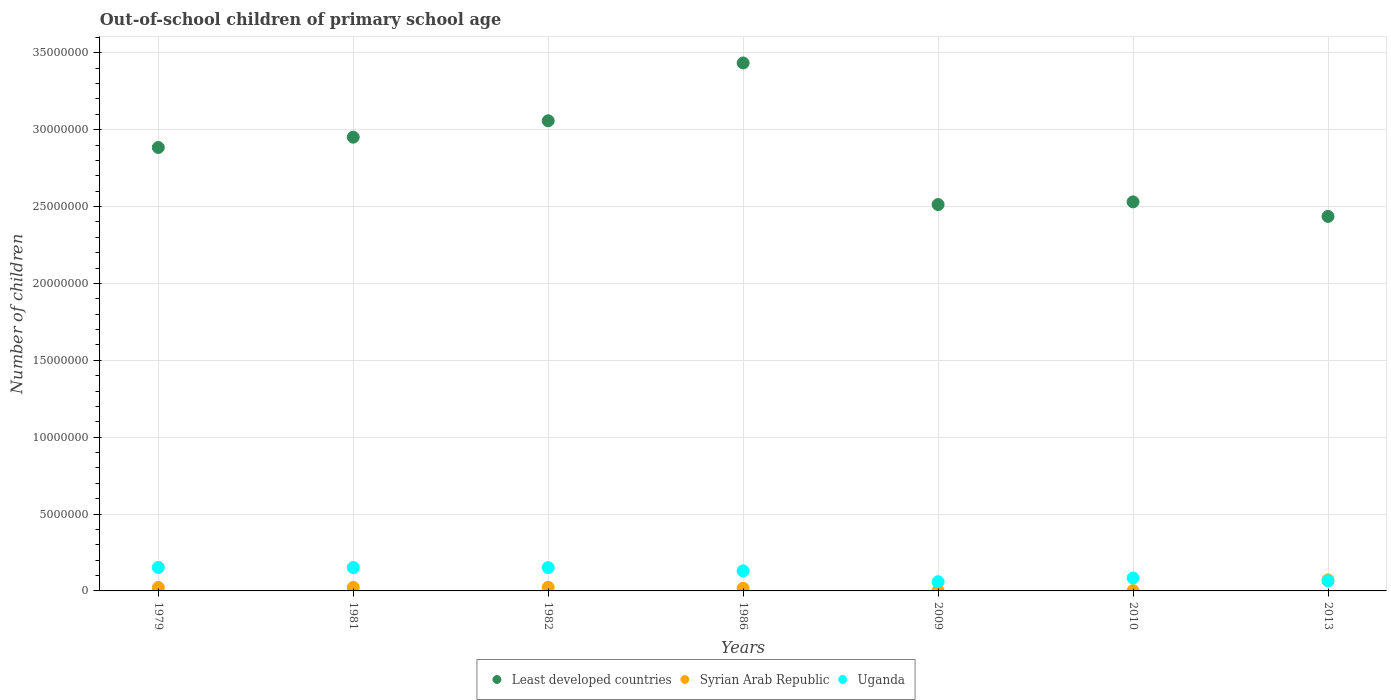What is the number of out-of-school children in Least developed countries in 2013?
Provide a succinct answer. 2.44e+07. Across all years, what is the maximum number of out-of-school children in Uganda?
Make the answer very short. 1.52e+06. Across all years, what is the minimum number of out-of-school children in Syrian Arab Republic?
Offer a very short reply. 1.86e+04. In which year was the number of out-of-school children in Least developed countries maximum?
Provide a succinct answer. 1986. In which year was the number of out-of-school children in Least developed countries minimum?
Offer a terse response. 2013. What is the total number of out-of-school children in Uganda in the graph?
Your answer should be very brief. 7.97e+06. What is the difference between the number of out-of-school children in Uganda in 1981 and that in 2009?
Offer a terse response. 9.25e+05. What is the difference between the number of out-of-school children in Least developed countries in 2013 and the number of out-of-school children in Uganda in 1981?
Provide a short and direct response. 2.28e+07. What is the average number of out-of-school children in Uganda per year?
Make the answer very short. 1.14e+06. In the year 2009, what is the difference between the number of out-of-school children in Syrian Arab Republic and number of out-of-school children in Uganda?
Make the answer very short. -5.76e+05. In how many years, is the number of out-of-school children in Syrian Arab Republic greater than 8000000?
Your answer should be very brief. 0. What is the ratio of the number of out-of-school children in Syrian Arab Republic in 2009 to that in 2010?
Give a very brief answer. 1.04. Is the number of out-of-school children in Syrian Arab Republic in 1986 less than that in 2013?
Keep it short and to the point. Yes. What is the difference between the highest and the second highest number of out-of-school children in Least developed countries?
Offer a terse response. 3.76e+06. What is the difference between the highest and the lowest number of out-of-school children in Least developed countries?
Your answer should be very brief. 9.98e+06. In how many years, is the number of out-of-school children in Least developed countries greater than the average number of out-of-school children in Least developed countries taken over all years?
Provide a succinct answer. 4. How many years are there in the graph?
Ensure brevity in your answer.  7. What is the difference between two consecutive major ticks on the Y-axis?
Provide a succinct answer. 5.00e+06. Are the values on the major ticks of Y-axis written in scientific E-notation?
Make the answer very short. No. Does the graph contain any zero values?
Your answer should be compact. No. How many legend labels are there?
Make the answer very short. 3. What is the title of the graph?
Provide a short and direct response. Out-of-school children of primary school age. Does "Namibia" appear as one of the legend labels in the graph?
Offer a terse response. No. What is the label or title of the Y-axis?
Ensure brevity in your answer.  Number of children. What is the Number of children of Least developed countries in 1979?
Your answer should be very brief. 2.88e+07. What is the Number of children of Syrian Arab Republic in 1979?
Your response must be concise. 2.24e+05. What is the Number of children in Uganda in 1979?
Make the answer very short. 1.52e+06. What is the Number of children of Least developed countries in 1981?
Offer a very short reply. 2.95e+07. What is the Number of children in Syrian Arab Republic in 1981?
Your answer should be compact. 2.28e+05. What is the Number of children in Uganda in 1981?
Your answer should be very brief. 1.52e+06. What is the Number of children of Least developed countries in 1982?
Offer a very short reply. 3.06e+07. What is the Number of children in Syrian Arab Republic in 1982?
Your response must be concise. 2.33e+05. What is the Number of children of Uganda in 1982?
Your answer should be compact. 1.52e+06. What is the Number of children in Least developed countries in 1986?
Provide a succinct answer. 3.43e+07. What is the Number of children in Syrian Arab Republic in 1986?
Offer a terse response. 1.64e+05. What is the Number of children in Uganda in 1986?
Your answer should be very brief. 1.30e+06. What is the Number of children of Least developed countries in 2009?
Keep it short and to the point. 2.51e+07. What is the Number of children of Syrian Arab Republic in 2009?
Keep it short and to the point. 1.94e+04. What is the Number of children in Uganda in 2009?
Offer a very short reply. 5.96e+05. What is the Number of children in Least developed countries in 2010?
Ensure brevity in your answer.  2.53e+07. What is the Number of children of Syrian Arab Republic in 2010?
Ensure brevity in your answer.  1.86e+04. What is the Number of children in Uganda in 2010?
Your response must be concise. 8.40e+05. What is the Number of children of Least developed countries in 2013?
Offer a very short reply. 2.44e+07. What is the Number of children of Syrian Arab Republic in 2013?
Ensure brevity in your answer.  7.16e+05. What is the Number of children of Uganda in 2013?
Provide a succinct answer. 6.60e+05. Across all years, what is the maximum Number of children of Least developed countries?
Ensure brevity in your answer.  3.43e+07. Across all years, what is the maximum Number of children of Syrian Arab Republic?
Provide a short and direct response. 7.16e+05. Across all years, what is the maximum Number of children of Uganda?
Your response must be concise. 1.52e+06. Across all years, what is the minimum Number of children of Least developed countries?
Your answer should be compact. 2.44e+07. Across all years, what is the minimum Number of children of Syrian Arab Republic?
Offer a very short reply. 1.86e+04. Across all years, what is the minimum Number of children of Uganda?
Your answer should be compact. 5.96e+05. What is the total Number of children in Least developed countries in the graph?
Ensure brevity in your answer.  1.98e+08. What is the total Number of children in Syrian Arab Republic in the graph?
Offer a terse response. 1.60e+06. What is the total Number of children in Uganda in the graph?
Your response must be concise. 7.97e+06. What is the difference between the Number of children of Least developed countries in 1979 and that in 1981?
Provide a succinct answer. -6.71e+05. What is the difference between the Number of children of Syrian Arab Republic in 1979 and that in 1981?
Give a very brief answer. -4210. What is the difference between the Number of children of Uganda in 1979 and that in 1981?
Your response must be concise. 4531. What is the difference between the Number of children in Least developed countries in 1979 and that in 1982?
Provide a short and direct response. -1.74e+06. What is the difference between the Number of children in Syrian Arab Republic in 1979 and that in 1982?
Make the answer very short. -9060. What is the difference between the Number of children of Uganda in 1979 and that in 1982?
Provide a short and direct response. 4746. What is the difference between the Number of children in Least developed countries in 1979 and that in 1986?
Provide a succinct answer. -5.50e+06. What is the difference between the Number of children of Syrian Arab Republic in 1979 and that in 1986?
Offer a very short reply. 5.96e+04. What is the difference between the Number of children in Uganda in 1979 and that in 1986?
Your answer should be compact. 2.20e+05. What is the difference between the Number of children of Least developed countries in 1979 and that in 2009?
Give a very brief answer. 3.71e+06. What is the difference between the Number of children of Syrian Arab Republic in 1979 and that in 2009?
Your response must be concise. 2.05e+05. What is the difference between the Number of children in Uganda in 1979 and that in 2009?
Provide a short and direct response. 9.29e+05. What is the difference between the Number of children in Least developed countries in 1979 and that in 2010?
Your answer should be very brief. 3.54e+06. What is the difference between the Number of children in Syrian Arab Republic in 1979 and that in 2010?
Give a very brief answer. 2.05e+05. What is the difference between the Number of children in Uganda in 1979 and that in 2010?
Provide a succinct answer. 6.84e+05. What is the difference between the Number of children in Least developed countries in 1979 and that in 2013?
Give a very brief answer. 4.48e+06. What is the difference between the Number of children of Syrian Arab Republic in 1979 and that in 2013?
Make the answer very short. -4.92e+05. What is the difference between the Number of children in Uganda in 1979 and that in 2013?
Your response must be concise. 8.65e+05. What is the difference between the Number of children in Least developed countries in 1981 and that in 1982?
Give a very brief answer. -1.07e+06. What is the difference between the Number of children in Syrian Arab Republic in 1981 and that in 1982?
Provide a short and direct response. -4850. What is the difference between the Number of children in Uganda in 1981 and that in 1982?
Your answer should be compact. 215. What is the difference between the Number of children of Least developed countries in 1981 and that in 1986?
Your response must be concise. -4.83e+06. What is the difference between the Number of children of Syrian Arab Republic in 1981 and that in 1986?
Ensure brevity in your answer.  6.38e+04. What is the difference between the Number of children of Uganda in 1981 and that in 1986?
Offer a very short reply. 2.16e+05. What is the difference between the Number of children in Least developed countries in 1981 and that in 2009?
Keep it short and to the point. 4.38e+06. What is the difference between the Number of children of Syrian Arab Republic in 1981 and that in 2009?
Ensure brevity in your answer.  2.09e+05. What is the difference between the Number of children in Uganda in 1981 and that in 2009?
Your answer should be compact. 9.25e+05. What is the difference between the Number of children of Least developed countries in 1981 and that in 2010?
Your response must be concise. 4.21e+06. What is the difference between the Number of children in Syrian Arab Republic in 1981 and that in 2010?
Offer a very short reply. 2.10e+05. What is the difference between the Number of children in Uganda in 1981 and that in 2010?
Your answer should be compact. 6.80e+05. What is the difference between the Number of children of Least developed countries in 1981 and that in 2013?
Your response must be concise. 5.15e+06. What is the difference between the Number of children of Syrian Arab Republic in 1981 and that in 2013?
Your response must be concise. -4.87e+05. What is the difference between the Number of children of Uganda in 1981 and that in 2013?
Give a very brief answer. 8.60e+05. What is the difference between the Number of children in Least developed countries in 1982 and that in 1986?
Give a very brief answer. -3.76e+06. What is the difference between the Number of children in Syrian Arab Republic in 1982 and that in 1986?
Your answer should be compact. 6.86e+04. What is the difference between the Number of children of Uganda in 1982 and that in 1986?
Make the answer very short. 2.15e+05. What is the difference between the Number of children in Least developed countries in 1982 and that in 2009?
Provide a short and direct response. 5.45e+06. What is the difference between the Number of children of Syrian Arab Republic in 1982 and that in 2009?
Offer a very short reply. 2.14e+05. What is the difference between the Number of children of Uganda in 1982 and that in 2009?
Make the answer very short. 9.24e+05. What is the difference between the Number of children in Least developed countries in 1982 and that in 2010?
Keep it short and to the point. 5.28e+06. What is the difference between the Number of children of Syrian Arab Republic in 1982 and that in 2010?
Provide a succinct answer. 2.14e+05. What is the difference between the Number of children of Uganda in 1982 and that in 2010?
Provide a succinct answer. 6.80e+05. What is the difference between the Number of children of Least developed countries in 1982 and that in 2013?
Offer a very short reply. 6.22e+06. What is the difference between the Number of children in Syrian Arab Republic in 1982 and that in 2013?
Your response must be concise. -4.83e+05. What is the difference between the Number of children of Uganda in 1982 and that in 2013?
Provide a short and direct response. 8.60e+05. What is the difference between the Number of children of Least developed countries in 1986 and that in 2009?
Give a very brief answer. 9.21e+06. What is the difference between the Number of children in Syrian Arab Republic in 1986 and that in 2009?
Give a very brief answer. 1.45e+05. What is the difference between the Number of children in Uganda in 1986 and that in 2009?
Give a very brief answer. 7.09e+05. What is the difference between the Number of children of Least developed countries in 1986 and that in 2010?
Provide a short and direct response. 9.04e+06. What is the difference between the Number of children in Syrian Arab Republic in 1986 and that in 2010?
Give a very brief answer. 1.46e+05. What is the difference between the Number of children of Uganda in 1986 and that in 2010?
Your answer should be very brief. 4.64e+05. What is the difference between the Number of children in Least developed countries in 1986 and that in 2013?
Offer a terse response. 9.98e+06. What is the difference between the Number of children in Syrian Arab Republic in 1986 and that in 2013?
Your answer should be very brief. -5.51e+05. What is the difference between the Number of children in Uganda in 1986 and that in 2013?
Offer a very short reply. 6.45e+05. What is the difference between the Number of children in Least developed countries in 2009 and that in 2010?
Provide a succinct answer. -1.74e+05. What is the difference between the Number of children of Syrian Arab Republic in 2009 and that in 2010?
Keep it short and to the point. 802. What is the difference between the Number of children of Uganda in 2009 and that in 2010?
Make the answer very short. -2.45e+05. What is the difference between the Number of children in Least developed countries in 2009 and that in 2013?
Offer a terse response. 7.71e+05. What is the difference between the Number of children of Syrian Arab Republic in 2009 and that in 2013?
Your answer should be very brief. -6.96e+05. What is the difference between the Number of children in Uganda in 2009 and that in 2013?
Keep it short and to the point. -6.45e+04. What is the difference between the Number of children in Least developed countries in 2010 and that in 2013?
Your response must be concise. 9.45e+05. What is the difference between the Number of children in Syrian Arab Republic in 2010 and that in 2013?
Provide a short and direct response. -6.97e+05. What is the difference between the Number of children of Uganda in 2010 and that in 2013?
Give a very brief answer. 1.80e+05. What is the difference between the Number of children of Least developed countries in 1979 and the Number of children of Syrian Arab Republic in 1981?
Provide a short and direct response. 2.86e+07. What is the difference between the Number of children of Least developed countries in 1979 and the Number of children of Uganda in 1981?
Your response must be concise. 2.73e+07. What is the difference between the Number of children in Syrian Arab Republic in 1979 and the Number of children in Uganda in 1981?
Offer a terse response. -1.30e+06. What is the difference between the Number of children of Least developed countries in 1979 and the Number of children of Syrian Arab Republic in 1982?
Your answer should be compact. 2.86e+07. What is the difference between the Number of children of Least developed countries in 1979 and the Number of children of Uganda in 1982?
Give a very brief answer. 2.73e+07. What is the difference between the Number of children of Syrian Arab Republic in 1979 and the Number of children of Uganda in 1982?
Keep it short and to the point. -1.30e+06. What is the difference between the Number of children in Least developed countries in 1979 and the Number of children in Syrian Arab Republic in 1986?
Ensure brevity in your answer.  2.87e+07. What is the difference between the Number of children of Least developed countries in 1979 and the Number of children of Uganda in 1986?
Ensure brevity in your answer.  2.75e+07. What is the difference between the Number of children in Syrian Arab Republic in 1979 and the Number of children in Uganda in 1986?
Make the answer very short. -1.08e+06. What is the difference between the Number of children of Least developed countries in 1979 and the Number of children of Syrian Arab Republic in 2009?
Give a very brief answer. 2.88e+07. What is the difference between the Number of children of Least developed countries in 1979 and the Number of children of Uganda in 2009?
Give a very brief answer. 2.82e+07. What is the difference between the Number of children in Syrian Arab Republic in 1979 and the Number of children in Uganda in 2009?
Provide a short and direct response. -3.72e+05. What is the difference between the Number of children in Least developed countries in 1979 and the Number of children in Syrian Arab Republic in 2010?
Your response must be concise. 2.88e+07. What is the difference between the Number of children of Least developed countries in 1979 and the Number of children of Uganda in 2010?
Your answer should be compact. 2.80e+07. What is the difference between the Number of children in Syrian Arab Republic in 1979 and the Number of children in Uganda in 2010?
Your response must be concise. -6.16e+05. What is the difference between the Number of children in Least developed countries in 1979 and the Number of children in Syrian Arab Republic in 2013?
Provide a succinct answer. 2.81e+07. What is the difference between the Number of children in Least developed countries in 1979 and the Number of children in Uganda in 2013?
Offer a very short reply. 2.82e+07. What is the difference between the Number of children of Syrian Arab Republic in 1979 and the Number of children of Uganda in 2013?
Your answer should be compact. -4.36e+05. What is the difference between the Number of children of Least developed countries in 1981 and the Number of children of Syrian Arab Republic in 1982?
Make the answer very short. 2.93e+07. What is the difference between the Number of children of Least developed countries in 1981 and the Number of children of Uganda in 1982?
Your response must be concise. 2.80e+07. What is the difference between the Number of children of Syrian Arab Republic in 1981 and the Number of children of Uganda in 1982?
Provide a short and direct response. -1.29e+06. What is the difference between the Number of children in Least developed countries in 1981 and the Number of children in Syrian Arab Republic in 1986?
Your answer should be very brief. 2.93e+07. What is the difference between the Number of children of Least developed countries in 1981 and the Number of children of Uganda in 1986?
Ensure brevity in your answer.  2.82e+07. What is the difference between the Number of children of Syrian Arab Republic in 1981 and the Number of children of Uganda in 1986?
Keep it short and to the point. -1.08e+06. What is the difference between the Number of children in Least developed countries in 1981 and the Number of children in Syrian Arab Republic in 2009?
Offer a terse response. 2.95e+07. What is the difference between the Number of children in Least developed countries in 1981 and the Number of children in Uganda in 2009?
Make the answer very short. 2.89e+07. What is the difference between the Number of children in Syrian Arab Republic in 1981 and the Number of children in Uganda in 2009?
Provide a succinct answer. -3.67e+05. What is the difference between the Number of children of Least developed countries in 1981 and the Number of children of Syrian Arab Republic in 2010?
Keep it short and to the point. 2.95e+07. What is the difference between the Number of children of Least developed countries in 1981 and the Number of children of Uganda in 2010?
Give a very brief answer. 2.87e+07. What is the difference between the Number of children in Syrian Arab Republic in 1981 and the Number of children in Uganda in 2010?
Your answer should be very brief. -6.12e+05. What is the difference between the Number of children in Least developed countries in 1981 and the Number of children in Syrian Arab Republic in 2013?
Make the answer very short. 2.88e+07. What is the difference between the Number of children in Least developed countries in 1981 and the Number of children in Uganda in 2013?
Provide a short and direct response. 2.89e+07. What is the difference between the Number of children in Syrian Arab Republic in 1981 and the Number of children in Uganda in 2013?
Offer a very short reply. -4.32e+05. What is the difference between the Number of children in Least developed countries in 1982 and the Number of children in Syrian Arab Republic in 1986?
Offer a very short reply. 3.04e+07. What is the difference between the Number of children in Least developed countries in 1982 and the Number of children in Uganda in 1986?
Your answer should be very brief. 2.93e+07. What is the difference between the Number of children of Syrian Arab Republic in 1982 and the Number of children of Uganda in 1986?
Your answer should be compact. -1.07e+06. What is the difference between the Number of children of Least developed countries in 1982 and the Number of children of Syrian Arab Republic in 2009?
Ensure brevity in your answer.  3.06e+07. What is the difference between the Number of children of Least developed countries in 1982 and the Number of children of Uganda in 2009?
Offer a terse response. 3.00e+07. What is the difference between the Number of children in Syrian Arab Republic in 1982 and the Number of children in Uganda in 2009?
Ensure brevity in your answer.  -3.63e+05. What is the difference between the Number of children in Least developed countries in 1982 and the Number of children in Syrian Arab Republic in 2010?
Offer a terse response. 3.06e+07. What is the difference between the Number of children in Least developed countries in 1982 and the Number of children in Uganda in 2010?
Provide a succinct answer. 2.97e+07. What is the difference between the Number of children in Syrian Arab Republic in 1982 and the Number of children in Uganda in 2010?
Offer a terse response. -6.07e+05. What is the difference between the Number of children of Least developed countries in 1982 and the Number of children of Syrian Arab Republic in 2013?
Offer a very short reply. 2.99e+07. What is the difference between the Number of children in Least developed countries in 1982 and the Number of children in Uganda in 2013?
Make the answer very short. 2.99e+07. What is the difference between the Number of children in Syrian Arab Republic in 1982 and the Number of children in Uganda in 2013?
Keep it short and to the point. -4.27e+05. What is the difference between the Number of children in Least developed countries in 1986 and the Number of children in Syrian Arab Republic in 2009?
Make the answer very short. 3.43e+07. What is the difference between the Number of children in Least developed countries in 1986 and the Number of children in Uganda in 2009?
Provide a short and direct response. 3.37e+07. What is the difference between the Number of children of Syrian Arab Republic in 1986 and the Number of children of Uganda in 2009?
Your response must be concise. -4.31e+05. What is the difference between the Number of children in Least developed countries in 1986 and the Number of children in Syrian Arab Republic in 2010?
Ensure brevity in your answer.  3.43e+07. What is the difference between the Number of children of Least developed countries in 1986 and the Number of children of Uganda in 2010?
Ensure brevity in your answer.  3.35e+07. What is the difference between the Number of children in Syrian Arab Republic in 1986 and the Number of children in Uganda in 2010?
Make the answer very short. -6.76e+05. What is the difference between the Number of children of Least developed countries in 1986 and the Number of children of Syrian Arab Republic in 2013?
Make the answer very short. 3.36e+07. What is the difference between the Number of children of Least developed countries in 1986 and the Number of children of Uganda in 2013?
Provide a succinct answer. 3.37e+07. What is the difference between the Number of children of Syrian Arab Republic in 1986 and the Number of children of Uganda in 2013?
Make the answer very short. -4.96e+05. What is the difference between the Number of children of Least developed countries in 2009 and the Number of children of Syrian Arab Republic in 2010?
Ensure brevity in your answer.  2.51e+07. What is the difference between the Number of children in Least developed countries in 2009 and the Number of children in Uganda in 2010?
Your answer should be very brief. 2.43e+07. What is the difference between the Number of children in Syrian Arab Republic in 2009 and the Number of children in Uganda in 2010?
Offer a very short reply. -8.21e+05. What is the difference between the Number of children in Least developed countries in 2009 and the Number of children in Syrian Arab Republic in 2013?
Keep it short and to the point. 2.44e+07. What is the difference between the Number of children of Least developed countries in 2009 and the Number of children of Uganda in 2013?
Offer a very short reply. 2.45e+07. What is the difference between the Number of children of Syrian Arab Republic in 2009 and the Number of children of Uganda in 2013?
Your answer should be very brief. -6.41e+05. What is the difference between the Number of children in Least developed countries in 2010 and the Number of children in Syrian Arab Republic in 2013?
Your answer should be compact. 2.46e+07. What is the difference between the Number of children of Least developed countries in 2010 and the Number of children of Uganda in 2013?
Keep it short and to the point. 2.46e+07. What is the difference between the Number of children of Syrian Arab Republic in 2010 and the Number of children of Uganda in 2013?
Offer a terse response. -6.41e+05. What is the average Number of children in Least developed countries per year?
Your answer should be very brief. 2.83e+07. What is the average Number of children in Syrian Arab Republic per year?
Ensure brevity in your answer.  2.29e+05. What is the average Number of children in Uganda per year?
Your response must be concise. 1.14e+06. In the year 1979, what is the difference between the Number of children of Least developed countries and Number of children of Syrian Arab Republic?
Your answer should be very brief. 2.86e+07. In the year 1979, what is the difference between the Number of children of Least developed countries and Number of children of Uganda?
Your response must be concise. 2.73e+07. In the year 1979, what is the difference between the Number of children of Syrian Arab Republic and Number of children of Uganda?
Offer a very short reply. -1.30e+06. In the year 1981, what is the difference between the Number of children of Least developed countries and Number of children of Syrian Arab Republic?
Your answer should be compact. 2.93e+07. In the year 1981, what is the difference between the Number of children in Least developed countries and Number of children in Uganda?
Ensure brevity in your answer.  2.80e+07. In the year 1981, what is the difference between the Number of children in Syrian Arab Republic and Number of children in Uganda?
Ensure brevity in your answer.  -1.29e+06. In the year 1982, what is the difference between the Number of children of Least developed countries and Number of children of Syrian Arab Republic?
Offer a terse response. 3.03e+07. In the year 1982, what is the difference between the Number of children in Least developed countries and Number of children in Uganda?
Ensure brevity in your answer.  2.91e+07. In the year 1982, what is the difference between the Number of children in Syrian Arab Republic and Number of children in Uganda?
Your response must be concise. -1.29e+06. In the year 1986, what is the difference between the Number of children of Least developed countries and Number of children of Syrian Arab Republic?
Offer a terse response. 3.42e+07. In the year 1986, what is the difference between the Number of children in Least developed countries and Number of children in Uganda?
Keep it short and to the point. 3.30e+07. In the year 1986, what is the difference between the Number of children of Syrian Arab Republic and Number of children of Uganda?
Ensure brevity in your answer.  -1.14e+06. In the year 2009, what is the difference between the Number of children of Least developed countries and Number of children of Syrian Arab Republic?
Keep it short and to the point. 2.51e+07. In the year 2009, what is the difference between the Number of children in Least developed countries and Number of children in Uganda?
Ensure brevity in your answer.  2.45e+07. In the year 2009, what is the difference between the Number of children in Syrian Arab Republic and Number of children in Uganda?
Your answer should be compact. -5.76e+05. In the year 2010, what is the difference between the Number of children of Least developed countries and Number of children of Syrian Arab Republic?
Provide a succinct answer. 2.53e+07. In the year 2010, what is the difference between the Number of children of Least developed countries and Number of children of Uganda?
Provide a succinct answer. 2.45e+07. In the year 2010, what is the difference between the Number of children of Syrian Arab Republic and Number of children of Uganda?
Provide a short and direct response. -8.22e+05. In the year 2013, what is the difference between the Number of children of Least developed countries and Number of children of Syrian Arab Republic?
Offer a very short reply. 2.36e+07. In the year 2013, what is the difference between the Number of children in Least developed countries and Number of children in Uganda?
Keep it short and to the point. 2.37e+07. In the year 2013, what is the difference between the Number of children in Syrian Arab Republic and Number of children in Uganda?
Provide a short and direct response. 5.56e+04. What is the ratio of the Number of children of Least developed countries in 1979 to that in 1981?
Make the answer very short. 0.98. What is the ratio of the Number of children of Syrian Arab Republic in 1979 to that in 1981?
Ensure brevity in your answer.  0.98. What is the ratio of the Number of children of Least developed countries in 1979 to that in 1982?
Give a very brief answer. 0.94. What is the ratio of the Number of children in Syrian Arab Republic in 1979 to that in 1982?
Keep it short and to the point. 0.96. What is the ratio of the Number of children of Uganda in 1979 to that in 1982?
Make the answer very short. 1. What is the ratio of the Number of children in Least developed countries in 1979 to that in 1986?
Your response must be concise. 0.84. What is the ratio of the Number of children of Syrian Arab Republic in 1979 to that in 1986?
Your answer should be very brief. 1.36. What is the ratio of the Number of children of Uganda in 1979 to that in 1986?
Offer a very short reply. 1.17. What is the ratio of the Number of children in Least developed countries in 1979 to that in 2009?
Your answer should be very brief. 1.15. What is the ratio of the Number of children in Syrian Arab Republic in 1979 to that in 2009?
Your response must be concise. 11.54. What is the ratio of the Number of children of Uganda in 1979 to that in 2009?
Make the answer very short. 2.56. What is the ratio of the Number of children in Least developed countries in 1979 to that in 2010?
Keep it short and to the point. 1.14. What is the ratio of the Number of children in Syrian Arab Republic in 1979 to that in 2010?
Your answer should be very brief. 12.04. What is the ratio of the Number of children of Uganda in 1979 to that in 2010?
Ensure brevity in your answer.  1.81. What is the ratio of the Number of children of Least developed countries in 1979 to that in 2013?
Give a very brief answer. 1.18. What is the ratio of the Number of children in Syrian Arab Republic in 1979 to that in 2013?
Your answer should be compact. 0.31. What is the ratio of the Number of children in Uganda in 1979 to that in 2013?
Your answer should be very brief. 2.31. What is the ratio of the Number of children in Least developed countries in 1981 to that in 1982?
Provide a short and direct response. 0.97. What is the ratio of the Number of children of Syrian Arab Republic in 1981 to that in 1982?
Your answer should be very brief. 0.98. What is the ratio of the Number of children of Uganda in 1981 to that in 1982?
Your answer should be compact. 1. What is the ratio of the Number of children of Least developed countries in 1981 to that in 1986?
Offer a terse response. 0.86. What is the ratio of the Number of children in Syrian Arab Republic in 1981 to that in 1986?
Provide a succinct answer. 1.39. What is the ratio of the Number of children of Uganda in 1981 to that in 1986?
Your answer should be compact. 1.17. What is the ratio of the Number of children of Least developed countries in 1981 to that in 2009?
Offer a terse response. 1.17. What is the ratio of the Number of children in Syrian Arab Republic in 1981 to that in 2009?
Your response must be concise. 11.76. What is the ratio of the Number of children of Uganda in 1981 to that in 2009?
Ensure brevity in your answer.  2.55. What is the ratio of the Number of children in Least developed countries in 1981 to that in 2010?
Ensure brevity in your answer.  1.17. What is the ratio of the Number of children of Syrian Arab Republic in 1981 to that in 2010?
Provide a short and direct response. 12.27. What is the ratio of the Number of children in Uganda in 1981 to that in 2010?
Ensure brevity in your answer.  1.81. What is the ratio of the Number of children of Least developed countries in 1981 to that in 2013?
Provide a short and direct response. 1.21. What is the ratio of the Number of children in Syrian Arab Republic in 1981 to that in 2013?
Your response must be concise. 0.32. What is the ratio of the Number of children in Uganda in 1981 to that in 2013?
Your response must be concise. 2.3. What is the ratio of the Number of children in Least developed countries in 1982 to that in 1986?
Make the answer very short. 0.89. What is the ratio of the Number of children in Syrian Arab Republic in 1982 to that in 1986?
Keep it short and to the point. 1.42. What is the ratio of the Number of children of Uganda in 1982 to that in 1986?
Offer a terse response. 1.17. What is the ratio of the Number of children of Least developed countries in 1982 to that in 2009?
Your answer should be very brief. 1.22. What is the ratio of the Number of children of Syrian Arab Republic in 1982 to that in 2009?
Your response must be concise. 12.01. What is the ratio of the Number of children of Uganda in 1982 to that in 2009?
Offer a very short reply. 2.55. What is the ratio of the Number of children of Least developed countries in 1982 to that in 2010?
Your answer should be compact. 1.21. What is the ratio of the Number of children in Syrian Arab Republic in 1982 to that in 2010?
Your answer should be very brief. 12.53. What is the ratio of the Number of children of Uganda in 1982 to that in 2010?
Offer a terse response. 1.81. What is the ratio of the Number of children in Least developed countries in 1982 to that in 2013?
Your answer should be compact. 1.26. What is the ratio of the Number of children of Syrian Arab Republic in 1982 to that in 2013?
Ensure brevity in your answer.  0.33. What is the ratio of the Number of children in Uganda in 1982 to that in 2013?
Keep it short and to the point. 2.3. What is the ratio of the Number of children in Least developed countries in 1986 to that in 2009?
Provide a succinct answer. 1.37. What is the ratio of the Number of children of Syrian Arab Republic in 1986 to that in 2009?
Offer a terse response. 8.47. What is the ratio of the Number of children in Uganda in 1986 to that in 2009?
Make the answer very short. 2.19. What is the ratio of the Number of children of Least developed countries in 1986 to that in 2010?
Keep it short and to the point. 1.36. What is the ratio of the Number of children in Syrian Arab Republic in 1986 to that in 2010?
Ensure brevity in your answer.  8.84. What is the ratio of the Number of children of Uganda in 1986 to that in 2010?
Provide a succinct answer. 1.55. What is the ratio of the Number of children in Least developed countries in 1986 to that in 2013?
Offer a very short reply. 1.41. What is the ratio of the Number of children in Syrian Arab Republic in 1986 to that in 2013?
Ensure brevity in your answer.  0.23. What is the ratio of the Number of children in Uganda in 1986 to that in 2013?
Your answer should be very brief. 1.98. What is the ratio of the Number of children in Syrian Arab Republic in 2009 to that in 2010?
Make the answer very short. 1.04. What is the ratio of the Number of children in Uganda in 2009 to that in 2010?
Provide a short and direct response. 0.71. What is the ratio of the Number of children in Least developed countries in 2009 to that in 2013?
Give a very brief answer. 1.03. What is the ratio of the Number of children of Syrian Arab Republic in 2009 to that in 2013?
Your answer should be very brief. 0.03. What is the ratio of the Number of children in Uganda in 2009 to that in 2013?
Offer a terse response. 0.9. What is the ratio of the Number of children in Least developed countries in 2010 to that in 2013?
Give a very brief answer. 1.04. What is the ratio of the Number of children of Syrian Arab Republic in 2010 to that in 2013?
Offer a very short reply. 0.03. What is the ratio of the Number of children of Uganda in 2010 to that in 2013?
Your answer should be very brief. 1.27. What is the difference between the highest and the second highest Number of children of Least developed countries?
Offer a terse response. 3.76e+06. What is the difference between the highest and the second highest Number of children of Syrian Arab Republic?
Provide a succinct answer. 4.83e+05. What is the difference between the highest and the second highest Number of children of Uganda?
Ensure brevity in your answer.  4531. What is the difference between the highest and the lowest Number of children of Least developed countries?
Provide a succinct answer. 9.98e+06. What is the difference between the highest and the lowest Number of children in Syrian Arab Republic?
Give a very brief answer. 6.97e+05. What is the difference between the highest and the lowest Number of children of Uganda?
Ensure brevity in your answer.  9.29e+05. 